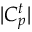<formula> <loc_0><loc_0><loc_500><loc_500>| C _ { p } ^ { t } |</formula> 